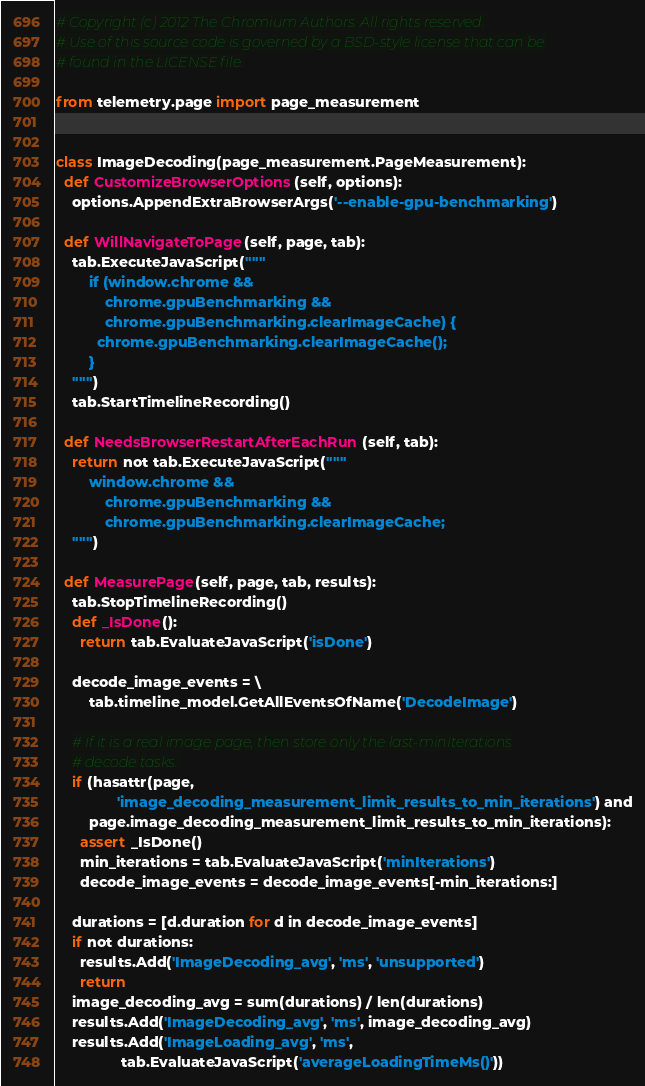Convert code to text. <code><loc_0><loc_0><loc_500><loc_500><_Python_># Copyright (c) 2012 The Chromium Authors. All rights reserved.
# Use of this source code is governed by a BSD-style license that can be
# found in the LICENSE file.

from telemetry.page import page_measurement


class ImageDecoding(page_measurement.PageMeasurement):
  def CustomizeBrowserOptions(self, options):
    options.AppendExtraBrowserArgs('--enable-gpu-benchmarking')

  def WillNavigateToPage(self, page, tab):
    tab.ExecuteJavaScript("""
        if (window.chrome &&
            chrome.gpuBenchmarking &&
            chrome.gpuBenchmarking.clearImageCache) {
          chrome.gpuBenchmarking.clearImageCache();
        }
    """)
    tab.StartTimelineRecording()

  def NeedsBrowserRestartAfterEachRun(self, tab):
    return not tab.ExecuteJavaScript("""
        window.chrome &&
            chrome.gpuBenchmarking &&
            chrome.gpuBenchmarking.clearImageCache;
    """)

  def MeasurePage(self, page, tab, results):
    tab.StopTimelineRecording()
    def _IsDone():
      return tab.EvaluateJavaScript('isDone')

    decode_image_events = \
        tab.timeline_model.GetAllEventsOfName('DecodeImage')

    # If it is a real image page, then store only the last-minIterations
    # decode tasks.
    if (hasattr(page,
               'image_decoding_measurement_limit_results_to_min_iterations') and
        page.image_decoding_measurement_limit_results_to_min_iterations):
      assert _IsDone()
      min_iterations = tab.EvaluateJavaScript('minIterations')
      decode_image_events = decode_image_events[-min_iterations:]

    durations = [d.duration for d in decode_image_events]
    if not durations:
      results.Add('ImageDecoding_avg', 'ms', 'unsupported')
      return
    image_decoding_avg = sum(durations) / len(durations)
    results.Add('ImageDecoding_avg', 'ms', image_decoding_avg)
    results.Add('ImageLoading_avg', 'ms',
                tab.EvaluateJavaScript('averageLoadingTimeMs()'))
</code> 